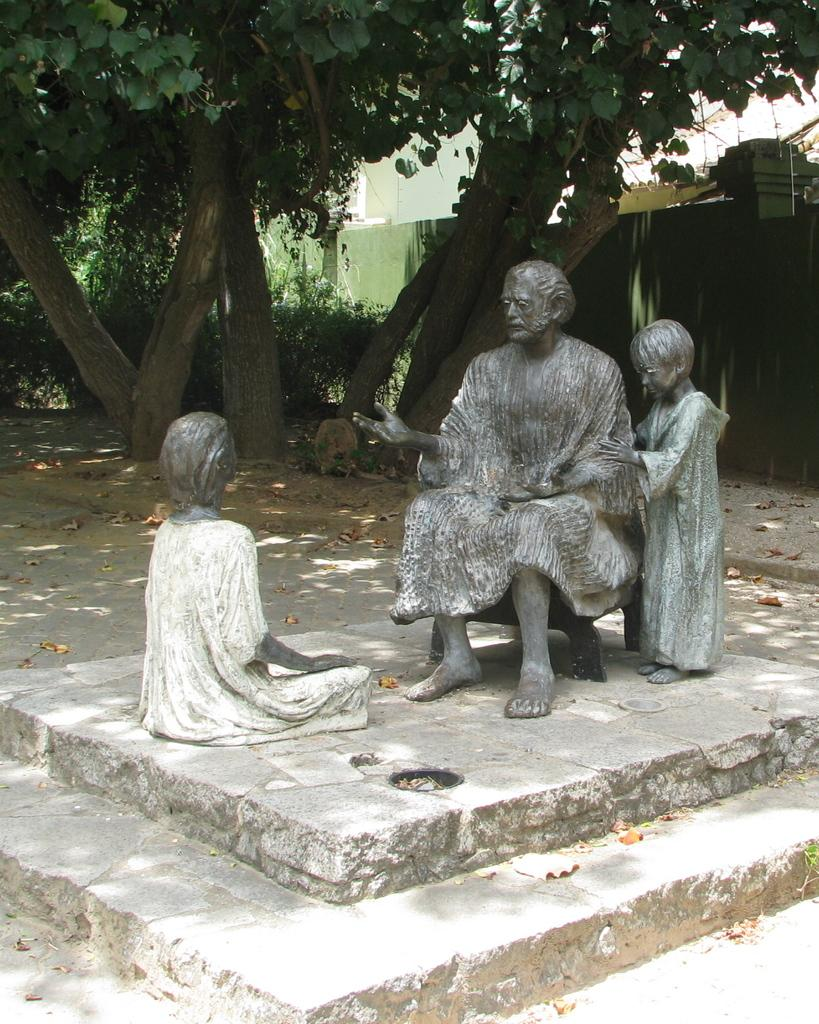What type of objects can be seen in the image? There are statues in the image. What other elements are present in the image besides the statues? There are trees and a wall in the image. What part of the brain can be seen in the image? There is no part of the brain present in the image; it features statues, trees, and a wall. 